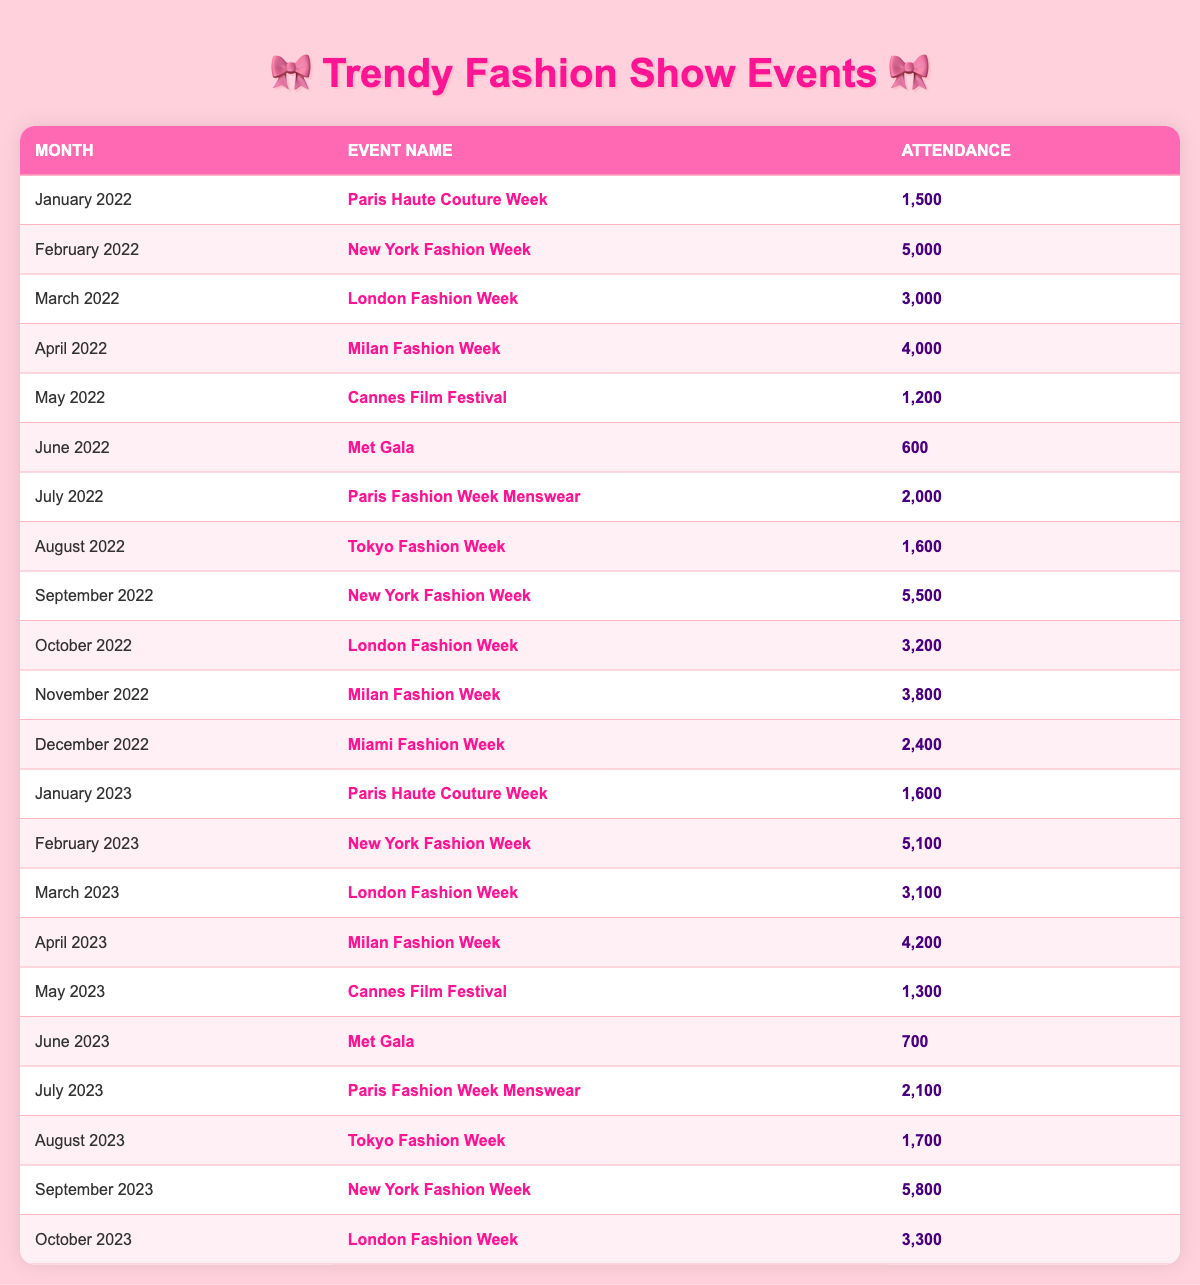What was the attendance at the Met Gala in June 2022? In the table, find the row for June 2022 where the event name is "Met Gala". The attendance value in that row is 600.
Answer: 600 How many people attended Milan Fashion Week in April 2023? Locate the row for April 2023 and check the attendance for "Milan Fashion Week", which is listed as 4,200.
Answer: 4,200 Which event had higher attendance: New York Fashion Week in February 2022 or September 2023? Compare the attendance values for both events: February 2022 has 5,000 and September 2023 has 5,800. Since 5,800 is greater than 5,000, September 2023 had higher attendance.
Answer: September 2023 What is the total attendance for the Cannes Film Festival over 2022 and 2023? Find values for the Cannes Film Festival: in May 2022, attendance is 1,200, and in May 2023, it is 1,300. Adding them together results in 1,200 + 1,300 = 2,500.
Answer: 2,500 Did the attendance at London Fashion Week increase from March 2022 to March 2023? Check the attendance for March 2022, which is 3,000, and March 2023, which is 3,100. Since 3,100 > 3,000, it confirms that the attendance increased.
Answer: Yes What is the average attendance across all fashion show events in 2022? Calculate the total attendance for each event in 2022: (1500 + 5000 + 3000 + 4000 + 1200 + 600 + 2000 + 1600 + 5500 + 3200 + 3800 + 2400) = 24,900. There are 12 events, so the average is 24,900 / 12 = 2,075.
Answer: 2,075 Which event had the highest attendance in 2022? Review the attendance for all events in 2022. The highest number is 5,500 for "New York Fashion Week" in September 2022.
Answer: New York Fashion Week How many events had attendance above 4,000 in 2022? Look at all the attendance values: Only February (5,000), September (5,500), April (4,000), and November (3,800) fit. Therefore, 3 events exceed 4,000.
Answer: 3 By how much did the attendance of New York Fashion Week change from February 2022 to February 2023? February 2022 had an attendance of 5,000 and February 2023 had 5,100. The difference is 5,100 - 5,000 = 100, indicating an increase of 100 attendees.
Answer: 100 Was the attendance at the Met Gala higher in June 2023 compared to June 2022? The attendance for June 2022 is 600 and for June 2023 is 700. Since 700 > 600, it shows that the attendance increased.
Answer: Yes 